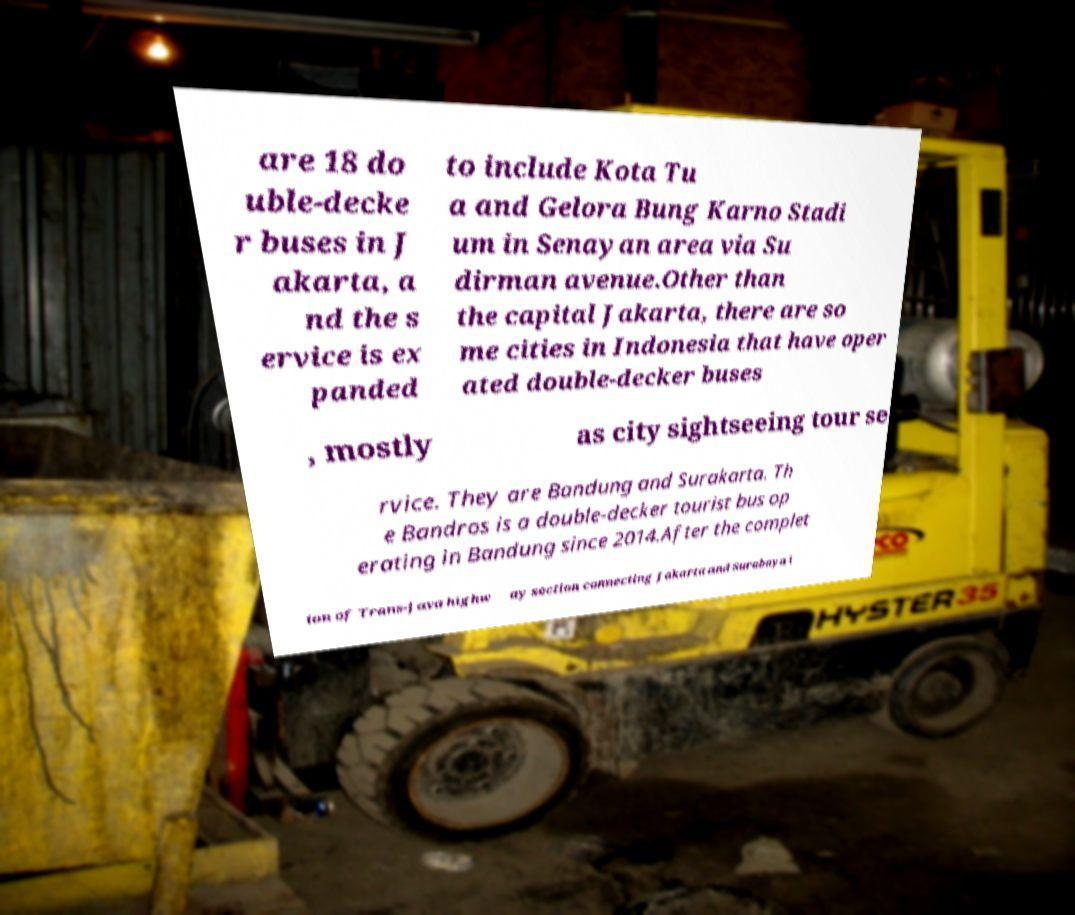For documentation purposes, I need the text within this image transcribed. Could you provide that? are 18 do uble-decke r buses in J akarta, a nd the s ervice is ex panded to include Kota Tu a and Gelora Bung Karno Stadi um in Senayan area via Su dirman avenue.Other than the capital Jakarta, there are so me cities in Indonesia that have oper ated double-decker buses , mostly as city sightseeing tour se rvice. They are Bandung and Surakarta. Th e Bandros is a double-decker tourist bus op erating in Bandung since 2014.After the complet ion of Trans-Java highw ay section connecting Jakarta and Surabaya i 